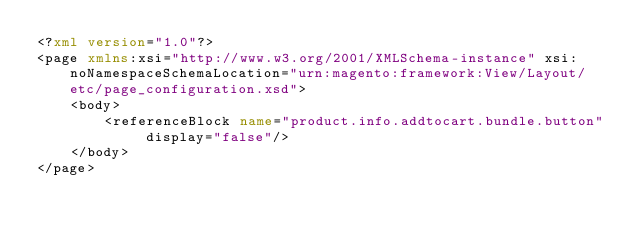<code> <loc_0><loc_0><loc_500><loc_500><_XML_><?xml version="1.0"?>
<page xmlns:xsi="http://www.w3.org/2001/XMLSchema-instance" xsi:noNamespaceSchemaLocation="urn:magento:framework:View/Layout/etc/page_configuration.xsd">
    <body>
        <referenceBlock name="product.info.addtocart.bundle.button" display="false"/>
    </body>
</page>
</code> 